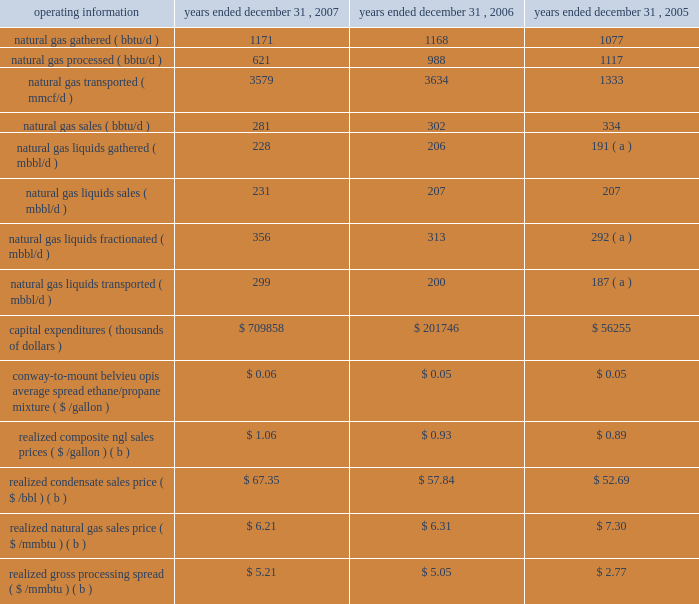
Operating results - we began consolidating our investment in oneok partners as of january 1 , 2006 , in accordance with eitf 04-5 .
We elected to use the prospective method , which results in our consolidated financial results and operating information including data for the legacy oneok partners operations beginning january 1 , 2006 .
For additional information , see 201csignificant accounting policies 201d in note a of the notes to consolidated financial statements in this annual report on form 10-k .
Net margin increased by $ 52.3 million in 2007 , compared with 2006 , primarily due to the following : 2022 increased performance of oneok partners 2019 natural gas liquids businesses , which benefited primarily from new supply connections that increased volumes gathered , transported , fractionated and sold , 2022 higher ngl product price spreads and higher isomerization price spreads in oneok partners 2019 natural gas liquids gathering and fractionation business , 2022 the incremental net margin related to the acquisition of assets from kinder morgan in october 2007 in oneok partners 2019 natural gas liquids pipelines business , and 2022 increased storage margins in oneok partners 2019 natural gas pipelines business , that was partially offset by 2022 decreased natural gas processing and transportation margins in oneok partners 2019 natural gas businesses resulting primarily from lower throughput , higher fuel costs and lower natural gas volumes processed as a result of various contract terminations .
Operating costs increased by $ 11.6 million during 2007 , compared with 2006 , primarily due to higher employee-related costs and the incremental operating expenses associated with the assets acquired from kinder morgan , partially offset by lower litigation costs .
Depreciation and amortization decreased by $ 8.3 million during 2007 , compared with 2006 , primarily due to a goodwill and asset impairment charge of $ 12.0 million recorded in the second quarter of 2006 related to black mesa pipeline .
Gain on sale of assets decreased by $ 113.5 million during 2007 , compared with 2006 , primarily due to the $ 113.9 million gain on the sale of a 20 percent partnership interest in northern border pipeline recorded in the second quarter of 2006 .
Equity earnings from investments for 2007 and 2006 primarily include earnings from oneok partners 2019 interest in northern border pipeline .
The decrease of $ 6.0 million during 2007 , compared with 2006 , is primarily due to the decrease in oneok partners 2019 share of northern border pipeline 2019s earnings from 70 percent in the first quarter of 2006 to 50 percent beginning in the second quarter of 2006 .
See page 75 for discussion of the disposition of the 20 percent partnership interest in northern border pipeline .
Allowance for equity funds used during construction increased for 2007 , compared with 2006 , due to oneok partners 2019 capital projects , which are discussed beginning on page 31. .
What were the increased one time benefits from non-cash charges from 2006 to 2007? 
Computations: ((8.3 + 12.0) * 1000000)
Answer: 20300000.0. 